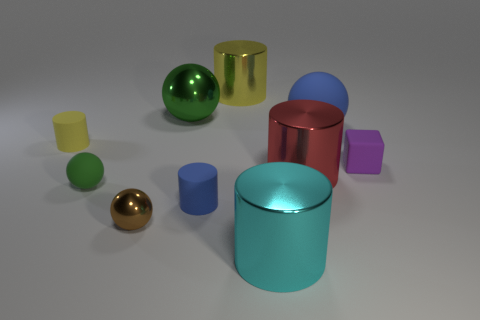What material is the tiny object that is in front of the red metal thing and to the left of the tiny brown shiny ball?
Your answer should be compact. Rubber. What shape is the tiny purple thing that is the same material as the tiny yellow cylinder?
Offer a very short reply. Cube. There is a green object that is made of the same material as the tiny yellow cylinder; what size is it?
Provide a succinct answer. Small. What shape is the shiny object that is left of the tiny blue object and behind the small brown metallic thing?
Your response must be concise. Sphere. There is a blue matte object that is in front of the matte cylinder that is on the left side of the brown shiny ball; what size is it?
Provide a succinct answer. Small. What shape is the matte object that is the same color as the big shiny sphere?
Your answer should be very brief. Sphere. Are the cylinder behind the big blue rubber thing and the big cyan object made of the same material?
Provide a succinct answer. Yes. The small ball to the left of the tiny ball that is in front of the blue rubber cylinder is made of what material?
Ensure brevity in your answer.  Rubber. There is a metallic ball that is behind the blue matte thing on the left side of the big yellow shiny thing behind the small brown metal sphere; what size is it?
Your answer should be compact. Large. Do the blue rubber object that is in front of the tiny purple rubber object and the cyan metallic object have the same shape?
Ensure brevity in your answer.  Yes. 